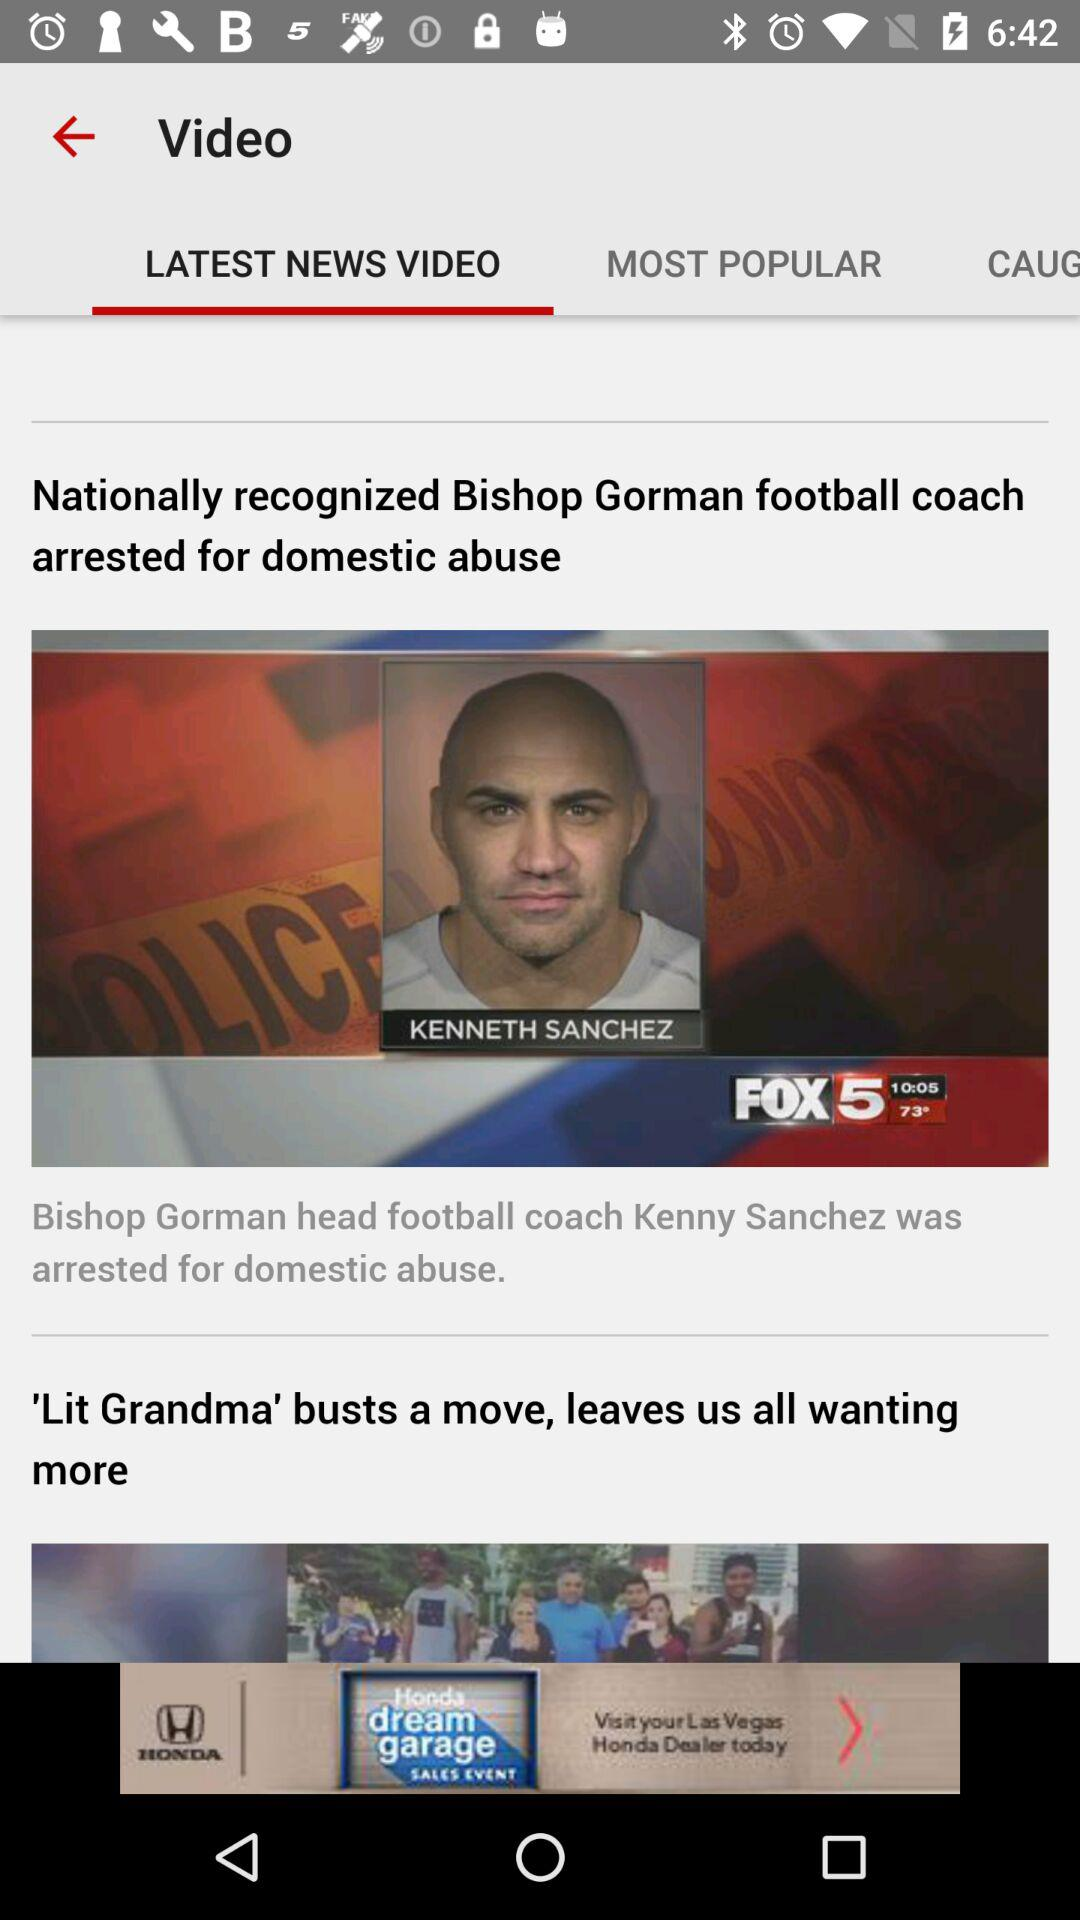How long is the news video about Kenneth Sanchez?
When the provided information is insufficient, respond with <no answer>. <no answer> 